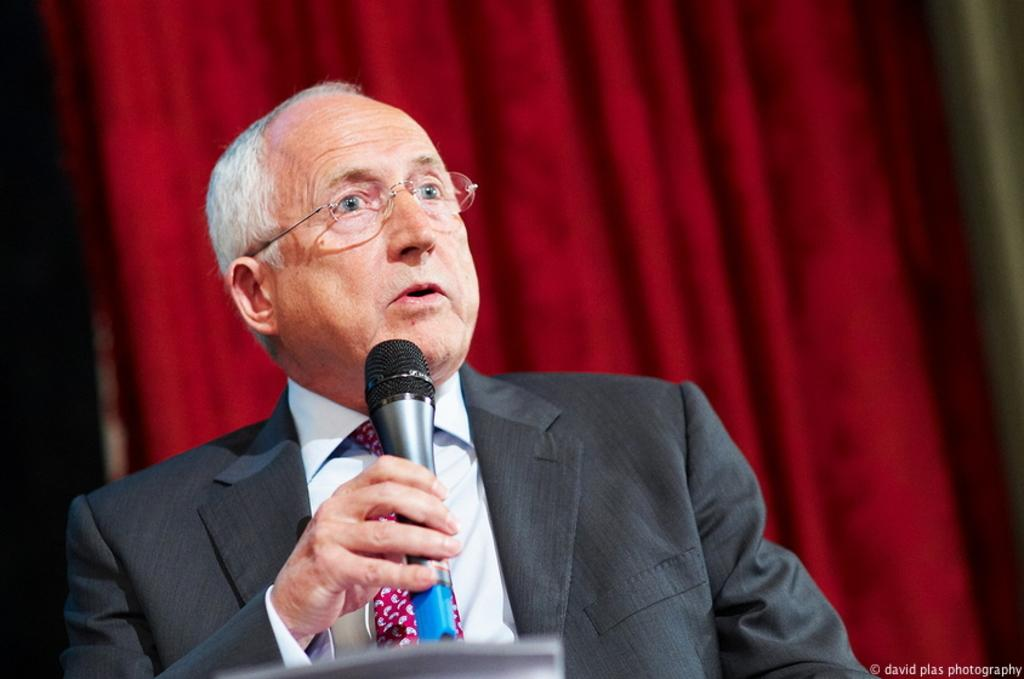Who is the person in the image? There is a man in the image. What is the man holding in the image? The man is holding a microphone. Can you describe any accessories the man is wearing in the image? The man is wearing glasses (specs) in the image. What is the name of the baby born in the image? There is no baby or birth event depicted in the image; it features a man holding a microphone and wearing glasses. 